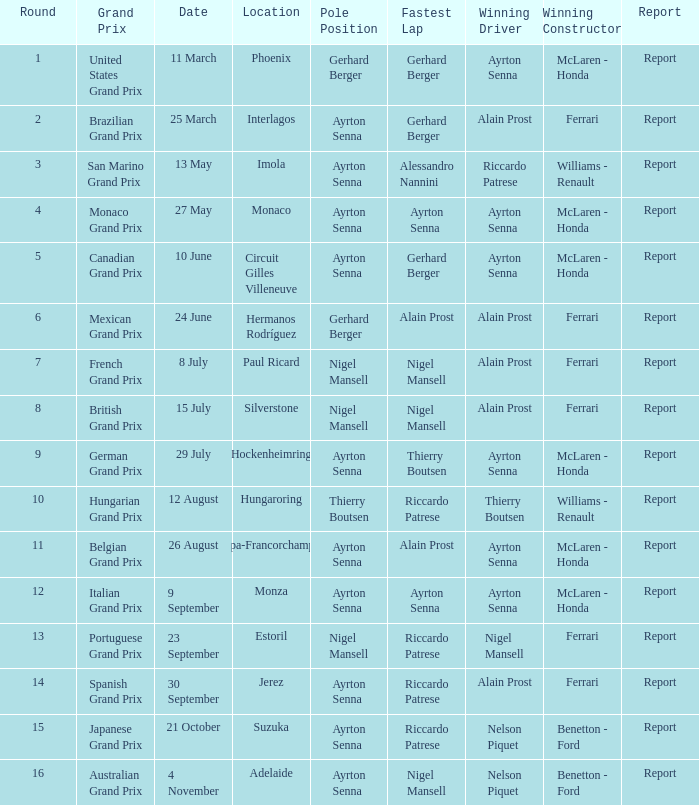What is the date that Ayrton Senna was the drive in Monza? 9 September. 